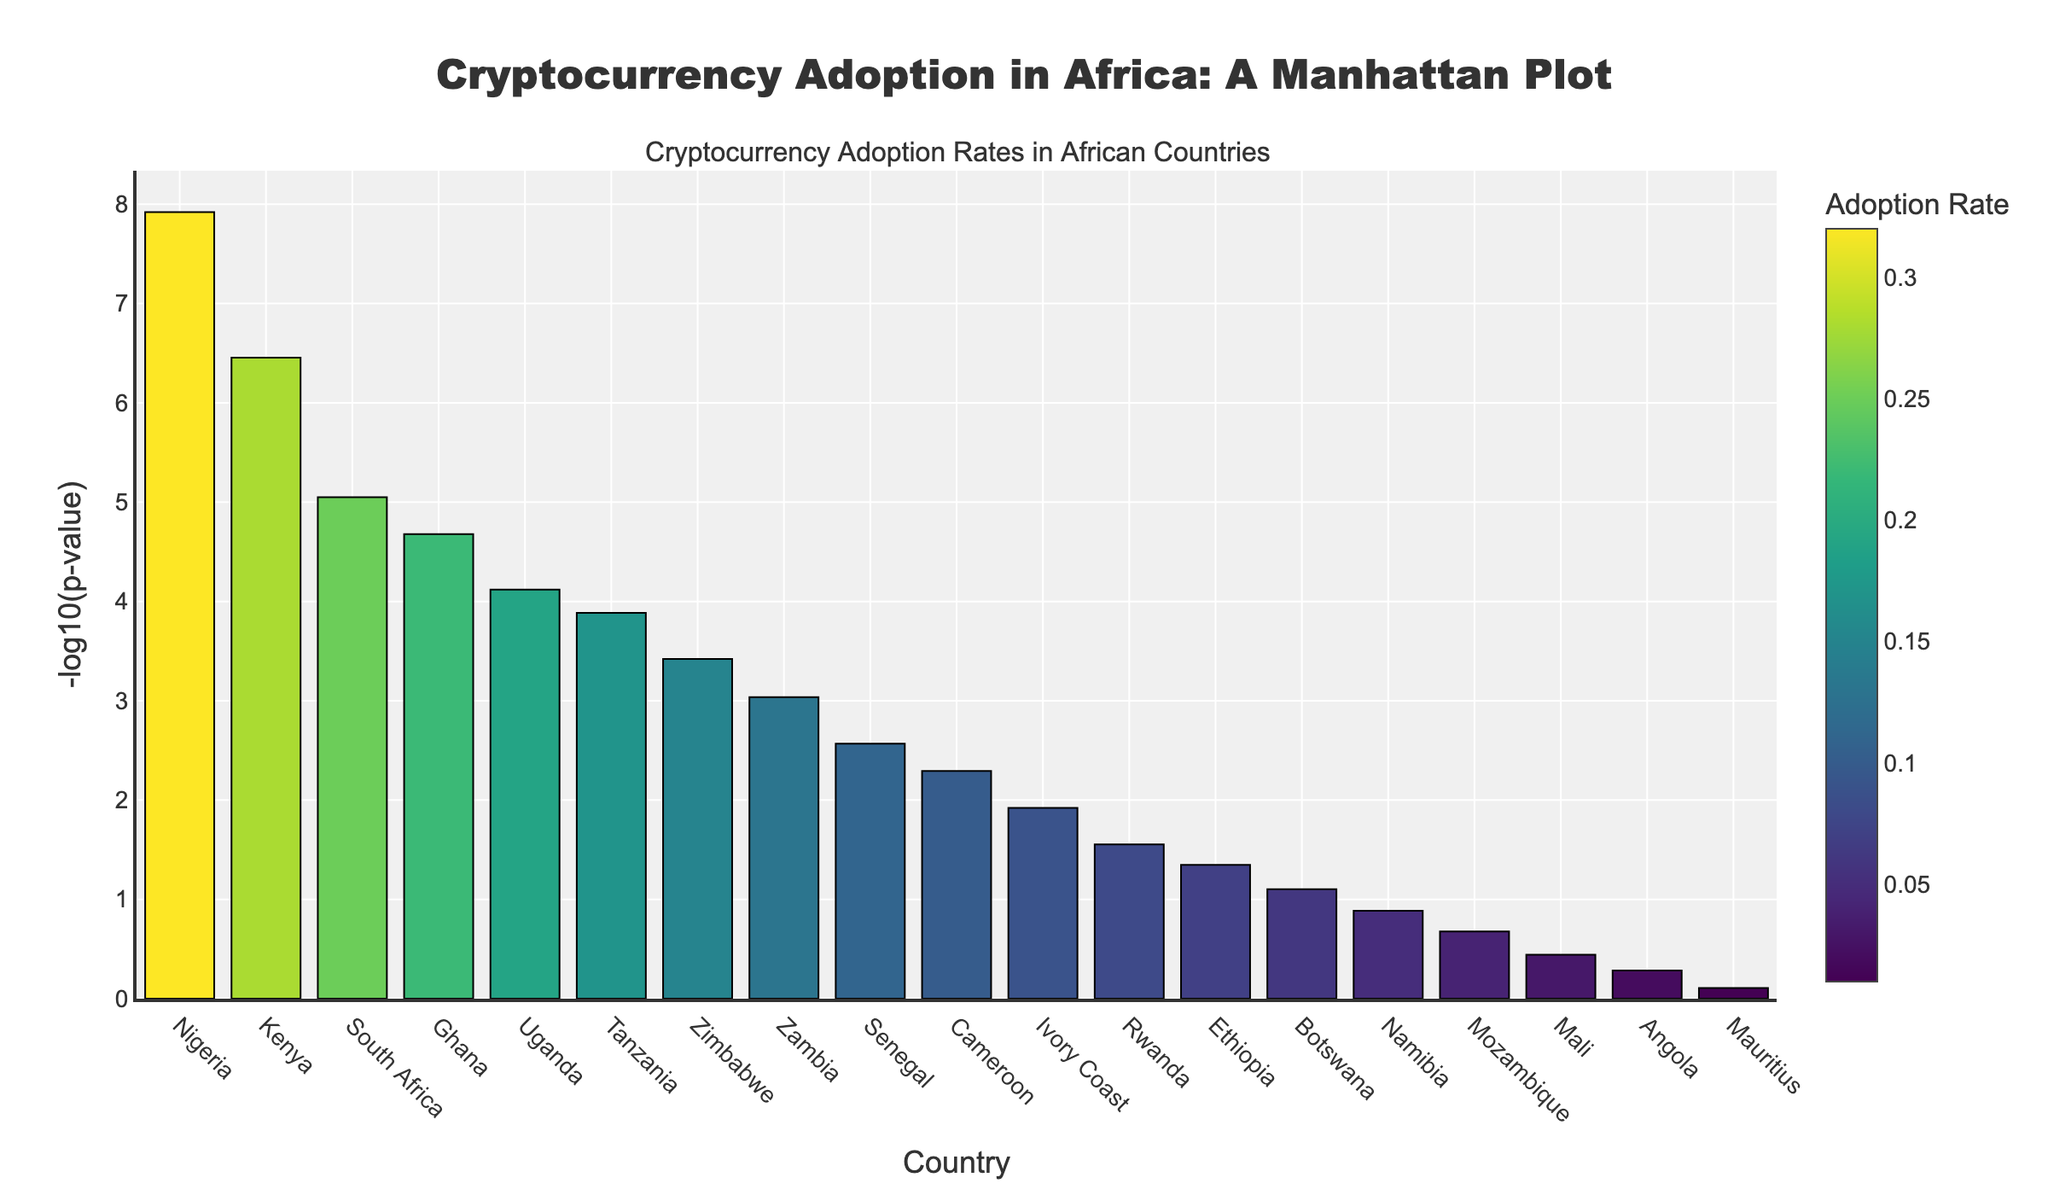What is the title of the plot? The title is typically given at the top of the plot. In this plot, the title is clearly mentioned.
Answer: "Cryptocurrency Adoption in Africa: A Manhattan Plot" Which country has the highest cryptocurrency adoption rate? The highest adoption rate corresponds to the darkest color intensity. Nigeria has the highest adoption rate indicated by the darkest bar.
Answer: Nigeria What does the y-axis represent in this plot? The y-axis represents the -log10 of the p-value, which is used to show statistical significance.
Answer: -log10(p-value) Which two countries have the lowest adoption rates? The two countries with the lightest color bars are at the bottom of the color scale. These countries are Angola and Mauritius.
Answer: Angola and Mauritius What is the adoption rate and -log10(p-value) for Kenya? Identify the bar corresponding to Kenya to see the adoption rate and look at the height of the bar for the -log10(p-value). The adoption rate for Kenya is 0.28 and the -log10(p-value) can be read from the y-axis or hover template as around 6.46.
Answer: 0.28 and 6.46 Which country has an adoption rate of 0.10 and how significant is its p-value? Find the bar with a color intensity that matches the adoption rate of 0.10, then check the height of the bar for the -log10(p-value). Cameroon has an adoption rate of 0.10 and its p-value's -log10 is around 2.29.
Answer: Cameroon with -log10(p-value) around 2.29 How does the adoption rate of South Africa compare to that of Zambia? Compare the color bar intensity of South Africa and Zambia. South Africa's adoption rate (0.25) is higher than Zambia's (0.13).
Answer: South Africa's rate is higher than Zambia's What is the rank of Uganda in terms of cryptocurrency adoption rate? Identify Uganda's bar and count the number of bars with higher adoption rates (darker intensity). Uganda's adoption rate of 0.19 places it above Tanzania, Zimbabwe, Zambia, Senegal, etc., making it the 5th highest.
Answer: 5th Identify the country with the third smallest -log10(p-value) and its adoption rate. Bars on the plot represent -log10(p-value), so the third smallest would be around 1.39. Identify that bar's color intensity for adoption rate. Rwanda fits this with a corresponding rate of 0.08.
Answer: Rwanda with adoption rate 0.08 What is the median -log10(p-value) among the displayed countries? Sort the countries by -log10(p-value) and find the middle value. With 19 countries, the 10th value corresponds to Ivory Coast at 1.92.
Answer: 1.92 